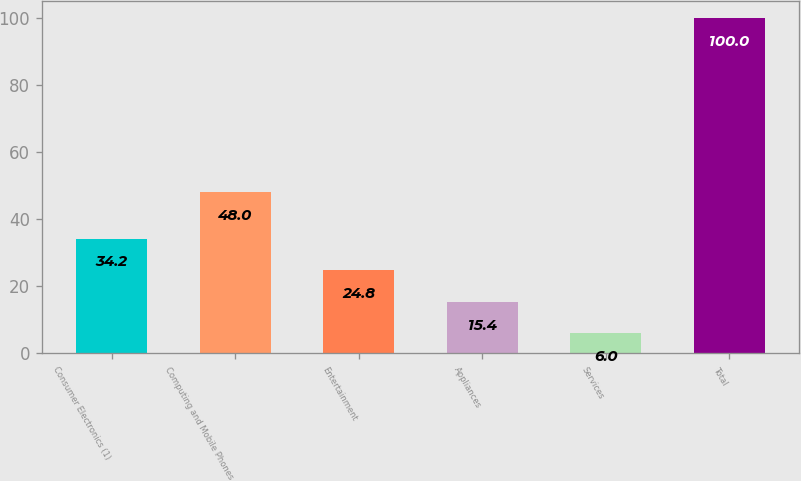Convert chart. <chart><loc_0><loc_0><loc_500><loc_500><bar_chart><fcel>Consumer Electronics (1)<fcel>Computing and Mobile Phones<fcel>Entertainment<fcel>Appliances<fcel>Services<fcel>Total<nl><fcel>34.2<fcel>48<fcel>24.8<fcel>15.4<fcel>6<fcel>100<nl></chart> 